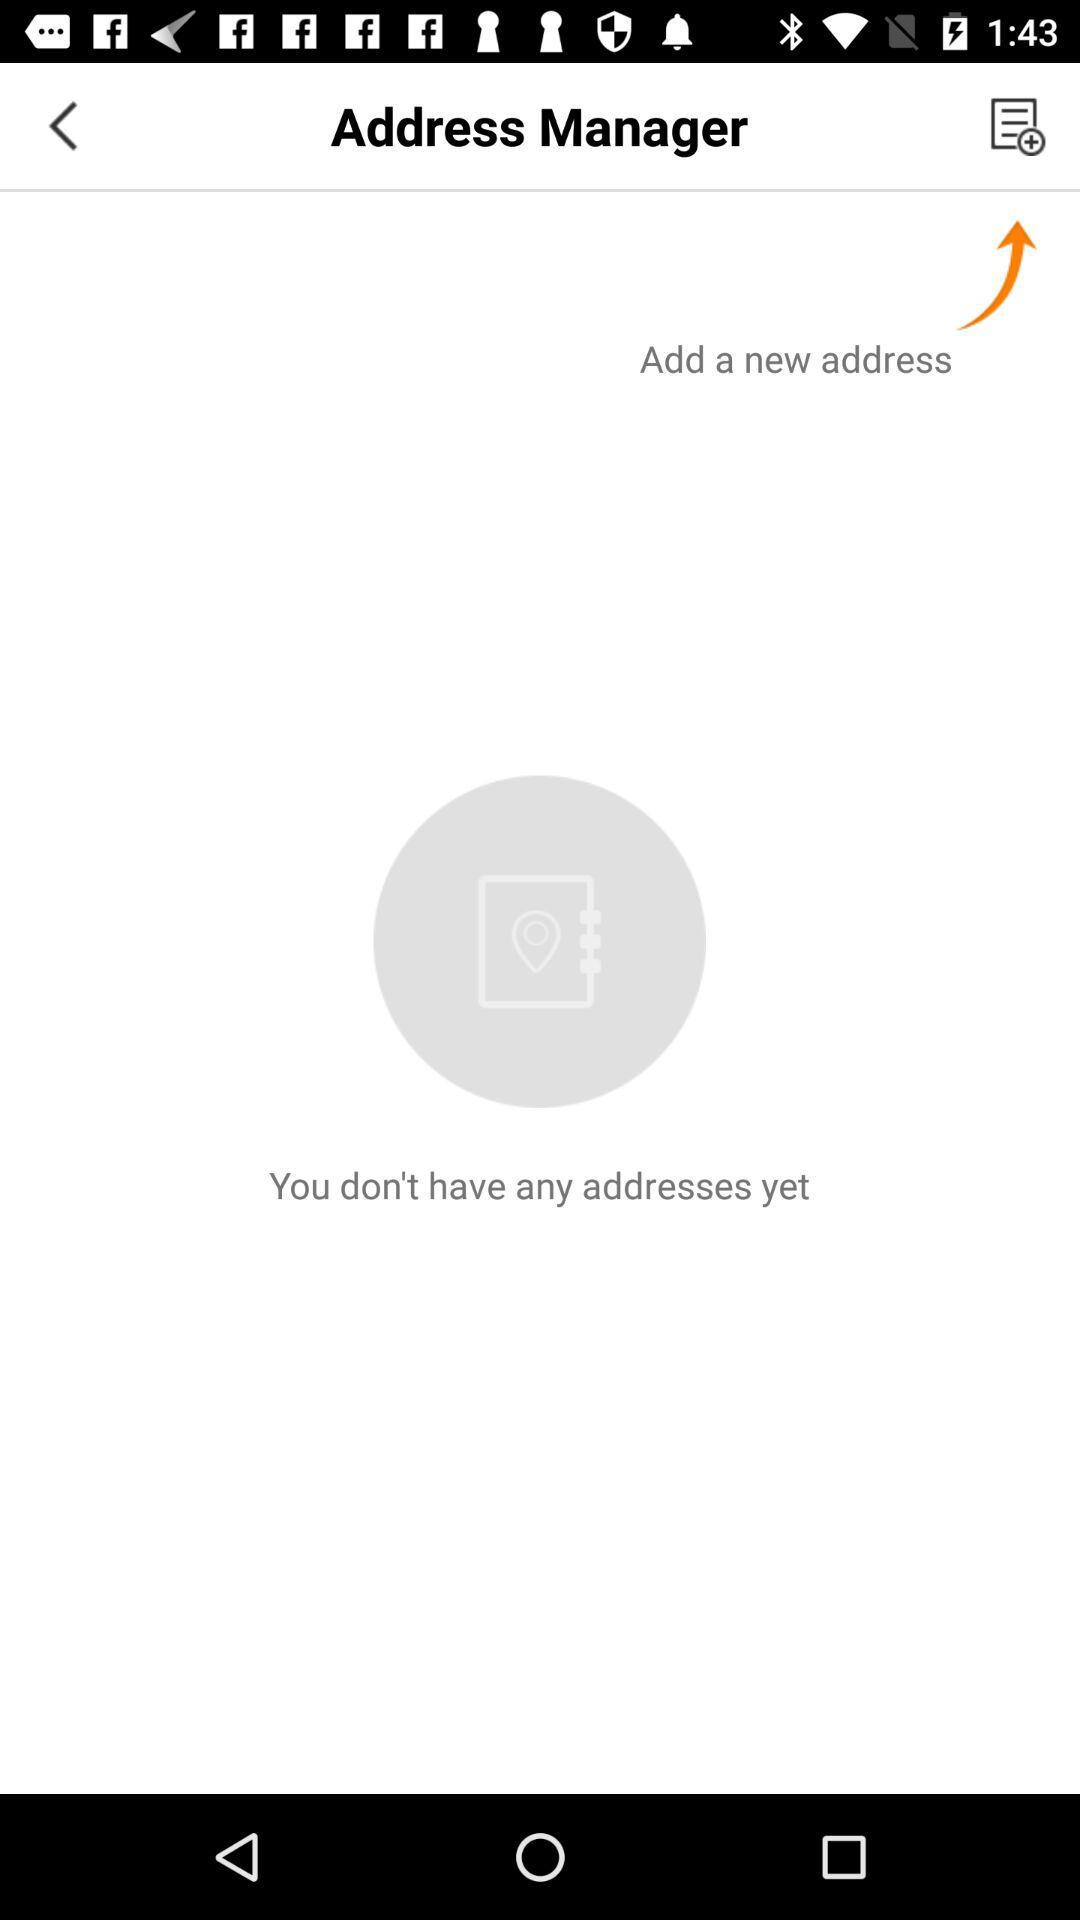How many addresses do I have?
Answer the question using a single word or phrase. 0 